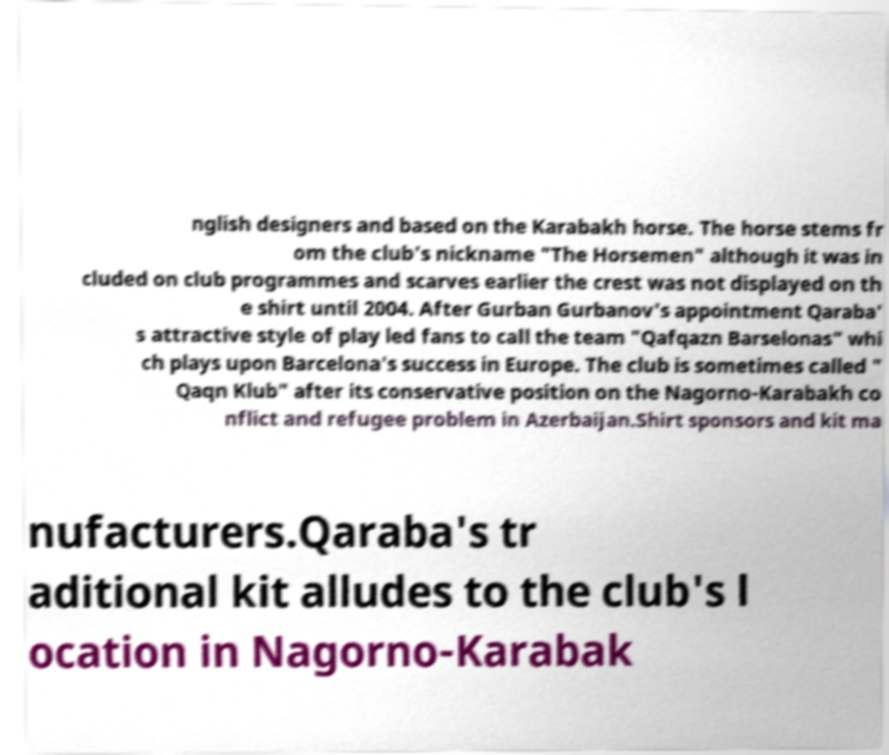Can you read and provide the text displayed in the image?This photo seems to have some interesting text. Can you extract and type it out for me? nglish designers and based on the Karabakh horse. The horse stems fr om the club's nickname "The Horsemen" although it was in cluded on club programmes and scarves earlier the crest was not displayed on th e shirt until 2004. After Gurban Gurbanov's appointment Qaraba' s attractive style of play led fans to call the team "Qafqazn Barselonas" whi ch plays upon Barcelona's success in Europe. The club is sometimes called " Qaqn Klub" after its conservative position on the Nagorno-Karabakh co nflict and refugee problem in Azerbaijan.Shirt sponsors and kit ma nufacturers.Qaraba's tr aditional kit alludes to the club's l ocation in Nagorno-Karabak 